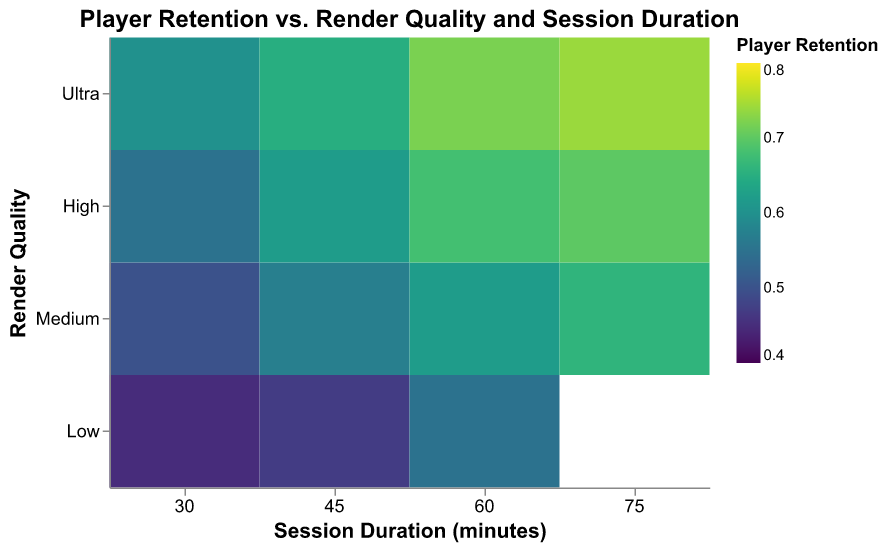What is the player retention rate for Medium render quality with a session duration of 60 minutes? The heatmap shows player retention rates based on render quality and session duration. To find the retention rate for Medium render quality and 60 minutes, locate the intersection of 'Medium' on the y-axis and '60' on the x-axis.
Answer: 0.62 What render quality shows the highest player retention rate for a session duration of 45 minutes? To determine this, examine the color intensity at 45 minutes across different render qualities. The deeper the color, the higher the retention. The deepest color at 45 minutes corresponds to 'Ultra' render quality.
Answer: Ultra Which session duration shows the highest average player retention rate for High render quality? For 'High' render quality, examine the colors representing different session durations. Calculating the average for 30 (0.55), 45 (0.62), 60 (0.68), and 75 (0.70) minutes provides: (0.55 + 0.62 + 0.68 + 0.70)/4 = 0.6375. The highest value within 'High' quality is 75 minutes.
Answer: 75 minutes How does player retention vary between Medium and High render quality at 60 minutes? Compare the retention rates at 60 minutes for 'Medium' (0.62) and 'High' (0.68) render quality. There is a visible increase in player retention from Medium to High quality.
Answer: Player retention is higher at High quality What trend do you observe in player retention as you move from Low to Ultra render quality for a session duration of 30 minutes? Observing the player retention rates at 30 minutes across render qualities Low (0.45), Medium (0.50), High (0.55), and Ultra (0.60), an increasing trend in player retention is evident.
Answer: Increasing trend Which render quality and session duration combination show the minimum player retention rate? To find the minimum retention rate, look for the lightest color. The value of 0.45 at Low quality and 30 minutes is the lowest.
Answer: Low, 30 minutes Does Ultra render quality always show higher player retention rates compared to Low render quality? Comparing corresponding values, Ultra render quality (0.60, 0.65, 0.72, 0.74) always exhibits higher or equal retention rates than Low (0.45, 0.47, 0.55) across all session durations.
Answer: Yes 